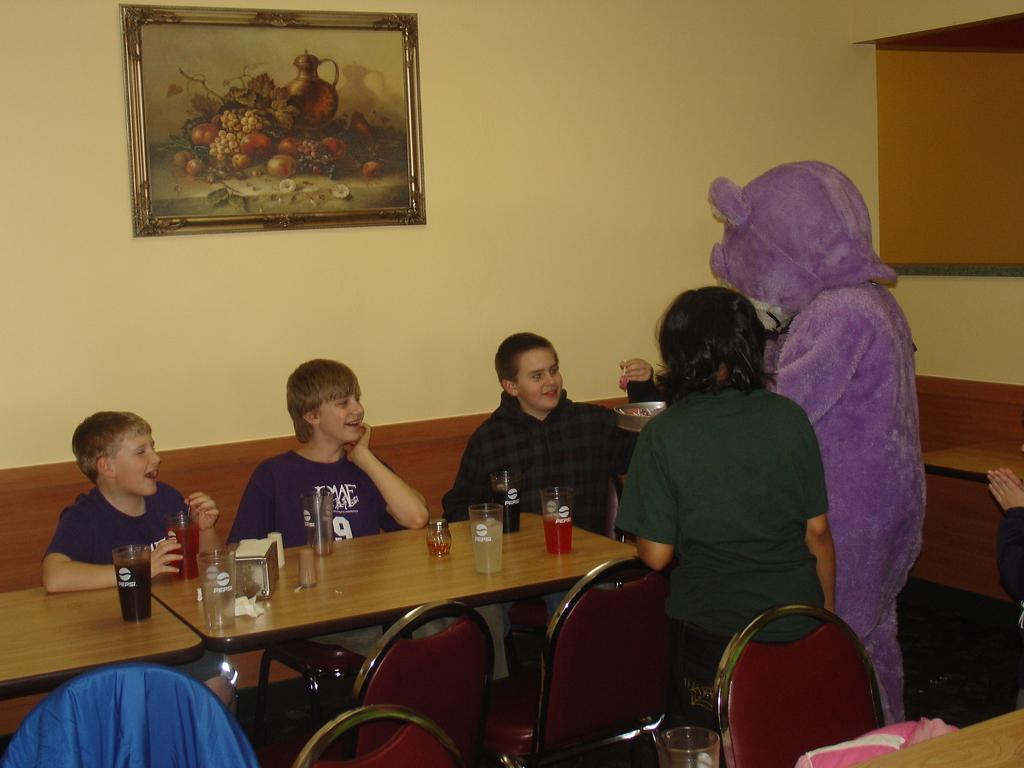What are the people in the image doing? There are people seated on a sofa and people standing in the image. What objects can be seen on a table in the image? There are glasses on a table in the image. What is hanging on a wall in the image? There is a photo frame on a wall in the image. What type of brush is being used to paint the afterthought in the image? There is no brush or painting activity present in the image. 